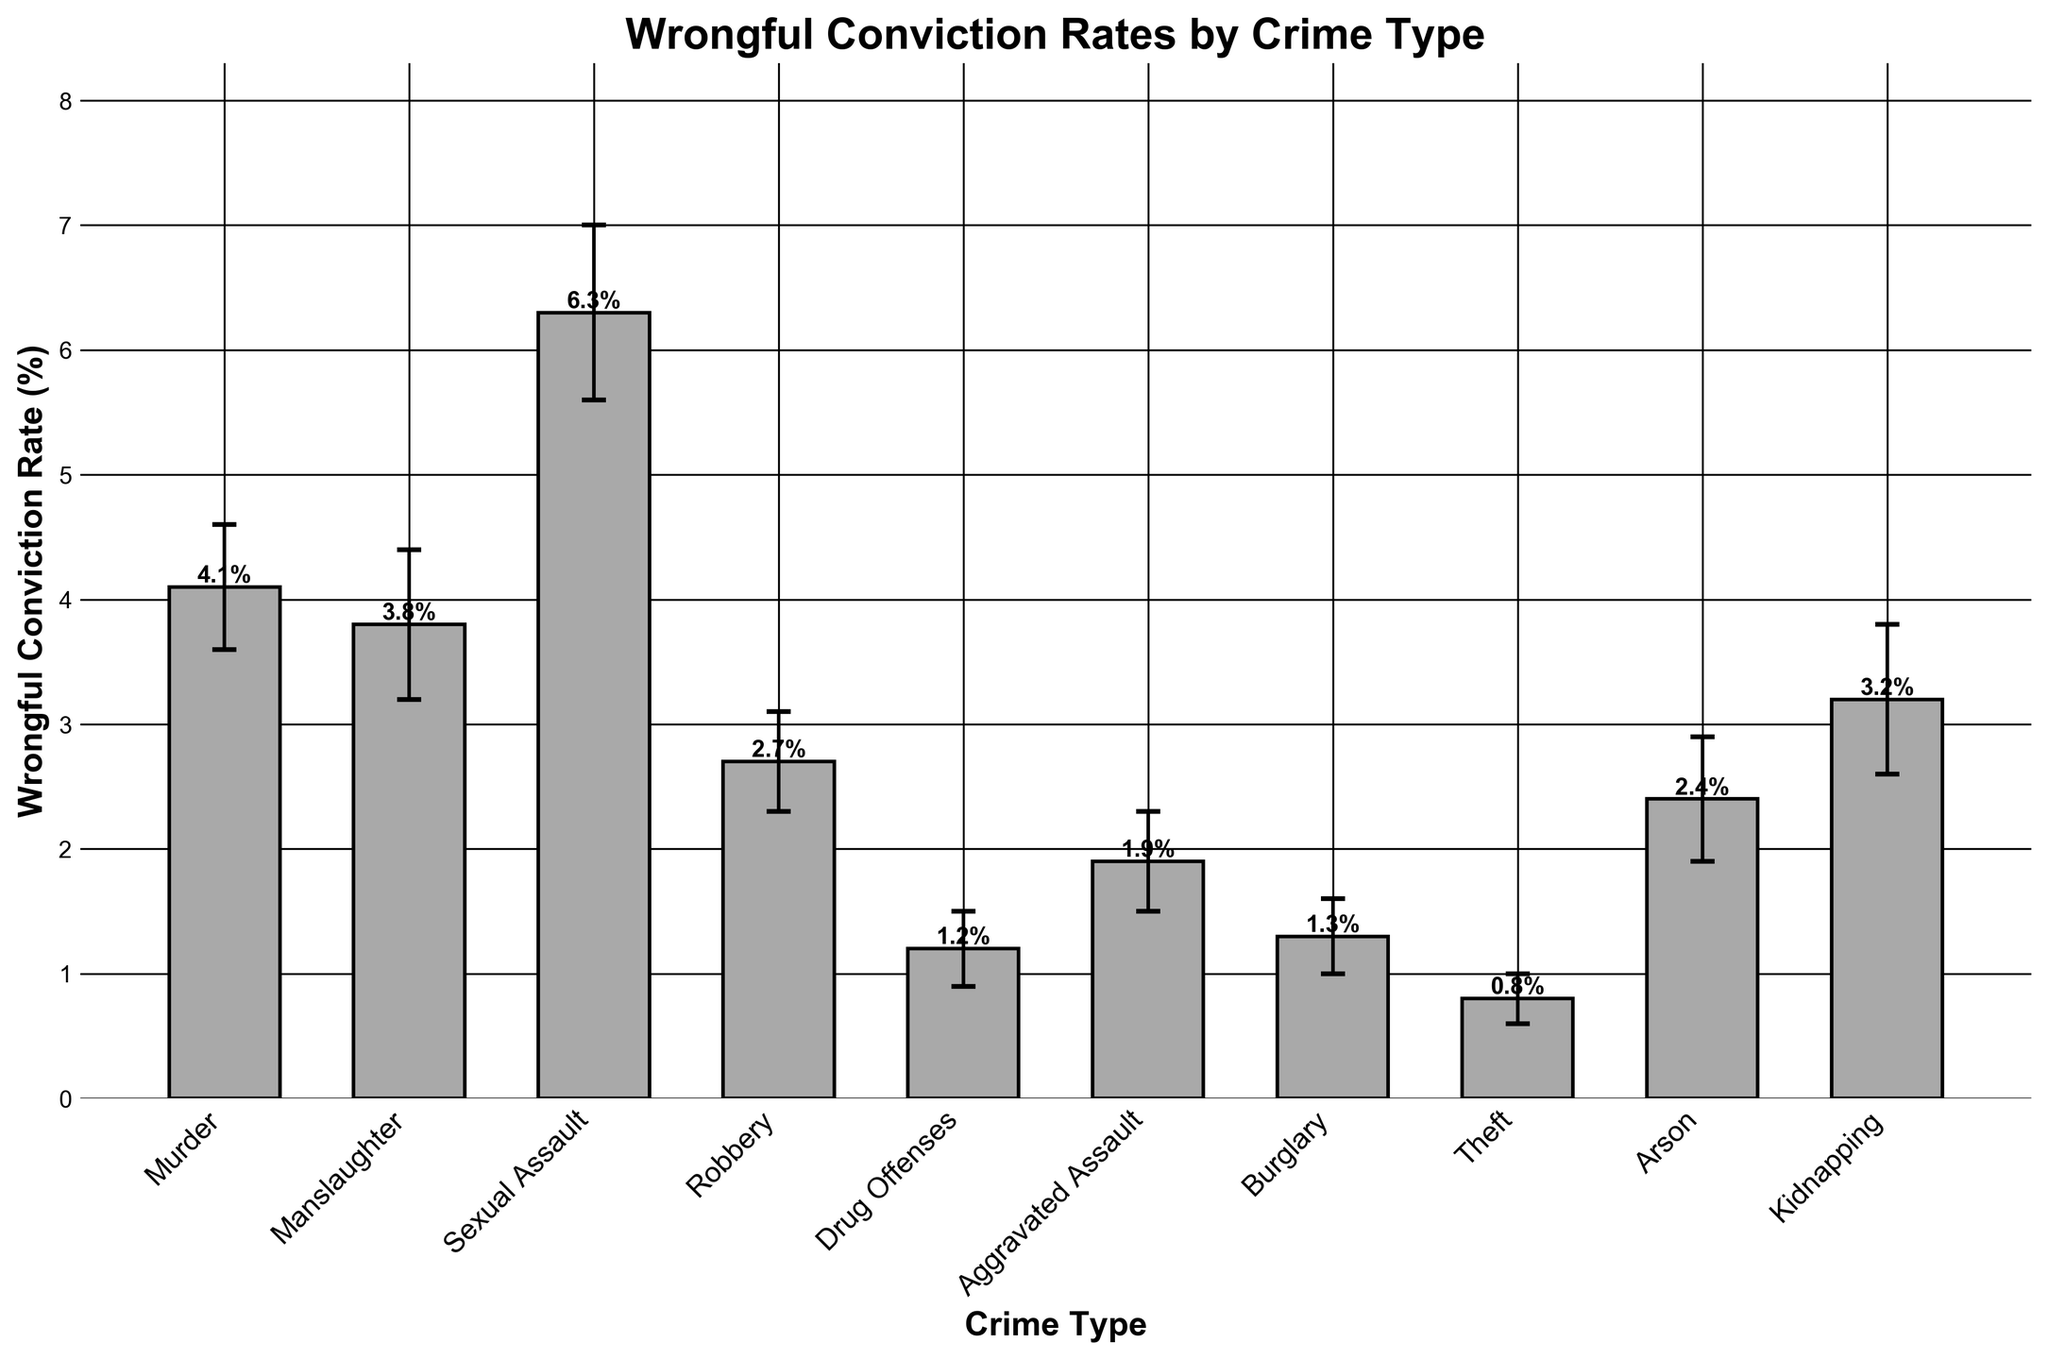What's the title of the figure? The title of the figure is located at the top and is bolded to stand out.
Answer: Wrongful Conviction Rates by Crime Type Which crime type has the highest wrongful conviction rate? By examining the heights of the bars, the tallest bar represents the highest wrongful conviction rate.
Answer: Sexual Assault How does the wrongful conviction rate for Murder compare to that for Manslaughter? By comparing the bars for Murder and Manslaughter, we see that the bar for Murder is slightly higher.
Answer: Murder is higher Which crime type has the lowest margin of error? Looking at the error bars for each crime type, identify the shortest one.
Answer: Theft Calculate the average wrongful conviction rate for the given crime types. Add up all the wrongful conviction rates and divide by the number of crime types. (4.1 + 3.8 + 6.3 + 2.7 + 1.2 + 1.9 + 1.3 + 0.8 + 2.4 + 3.2) / 10 = 2.87
Answer: 2.87 What is the difference in wrongful conviction rate between Drug Offenses and Arson? Subtract the wrongful conviction rate for Arson from that for Drug Offenses. 2.4 - 1.2 = 1.2
Answer: 1.2 Which three crime types have wrongful conviction rates greater than 3%? Identify the crime types with bars higher than the 3% mark.
Answer: Murder, Manslaughter, Sexual Assault, Kidnapping What is the range of the wrongful conviction rates (i.e., the difference between the highest and lowest rates)? Subtract the lowest rate from the highest rate. 6.3% (Sexual Assault) - 0.8% (Theft) = 5.5%
Answer: 5.5 How are the wrongful conviction rates visually represented in the figure? The wrongful conviction rates are shown as vertical bars, with heights representing the rates, and error bars indicating the margins of error.
Answer: Vertical bars with error bars Which crime type has the largest margin of error, and what is its value? Identify the longest error bar and refer to its corresponding data point.
Answer: Sexual Assault, 0.7 